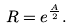<formula> <loc_0><loc_0><loc_500><loc_500>R = e ^ { \frac { A } { 2 } } .</formula> 